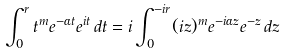Convert formula to latex. <formula><loc_0><loc_0><loc_500><loc_500>\int _ { 0 } ^ { r } t ^ { m } e ^ { - \alpha t } e ^ { i t } \, d t = i \int _ { 0 } ^ { - i r } ( i z ) ^ { m } e ^ { - i \alpha z } e ^ { - z } \, d z</formula> 